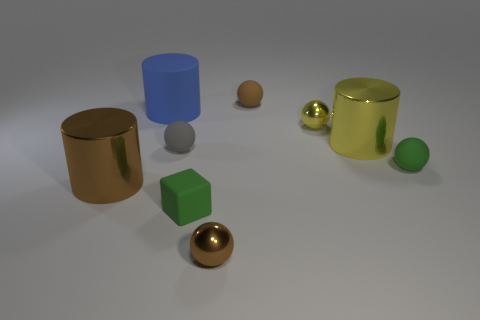There is a tiny shiny thing that is behind the large yellow metallic thing; what shape is it? The tiny shiny object located behind the large yellow metallic thing has a spherical shape. Its reflective surface and perfect roundness are characteristic traits of a sphere, which can be definitively identified even with its smaller visual footprint in relation to the surrounding objects. 